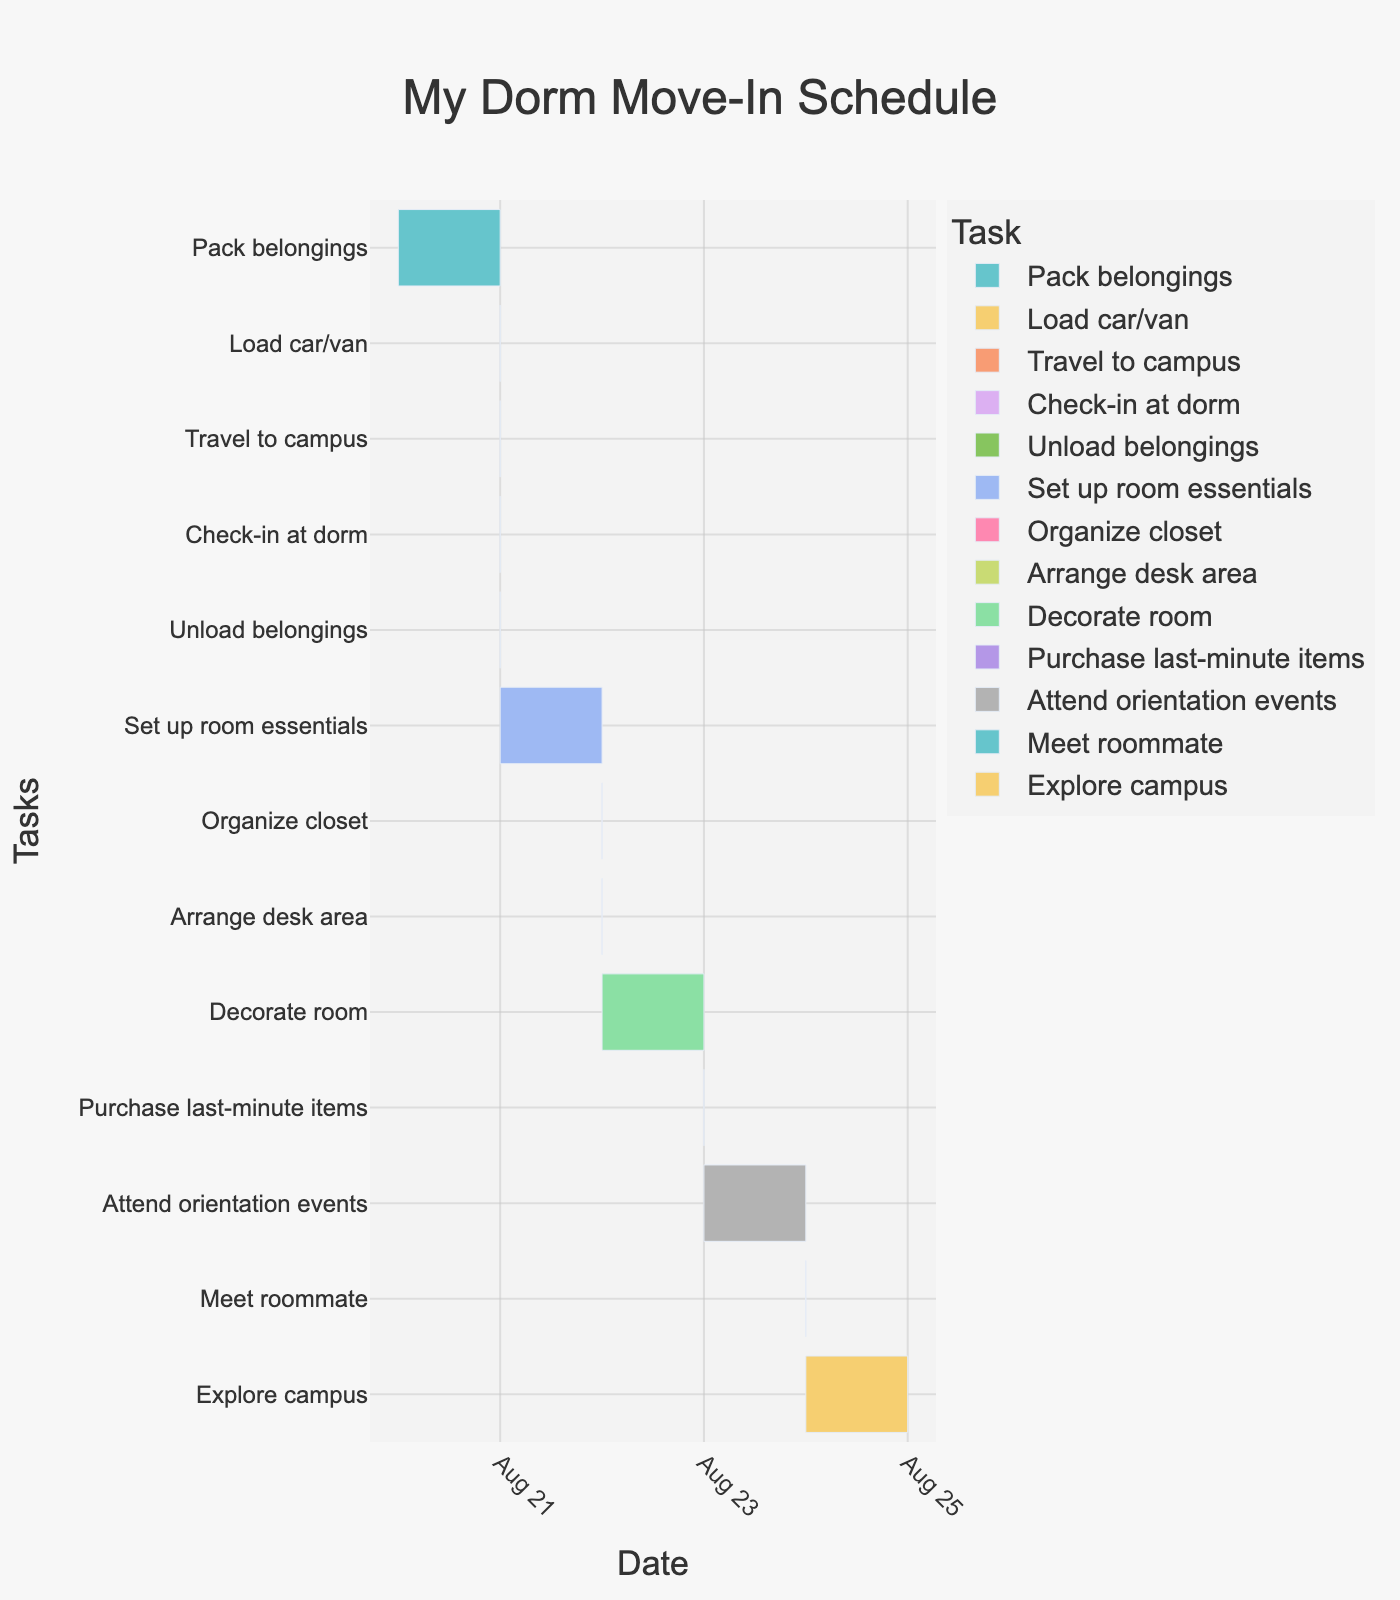What's the title of the Gantt Chart? The title of a chart is usually found at the top, indicating the subject or purpose of the chart.
Answer: My Dorm Move-In Schedule What is the duration of the 'Pack belongings' task? By looking at the task's bar on the chart, we can see that it starts on August 20 and ends on August 21. The duration is stated as 8 hours.
Answer: 8 hours How many tasks are scheduled to start on August 21? One can count the bars starting on August 21 directly from the chart. The tasks are 'Pack belongings', 'Load car/van', 'Travel to campus', 'Check-in at dorm', 'Unload belongings', and 'Set up room essentials'.
Answer: 6 Which task has the longest duration? By comparing the lengths of the bars on the chart, 'Attend orientation events' can be seen lasting from August 23 to August 24 with a duration of 8 hours.
Answer: Attend orientation events Which tasks overlap on August 23? By visually checking the tasks that span across August 23, 'Decorate room', 'Purchase last-minute items', and 'Attend orientation events' overlap on that date.
Answer: Decorate room, Purchase last-minute items, Attend orientation events How many hours in total are spent on tasks starting on August 22? Summing the durations of the tasks that start on August 22: 'Organize closet' (3 hours), 'Arrange desk area' (2 hours), and 'Decorate room' (4 hours).
Answer: 9 hours Compare the durations of 'Explore campus' and 'Set up room essentials'. Which one takes longer? By comparing the durations directly from the chart, 'Explore campus' lasts for 6 hours from August 24 to August 25, while 'Set up room essentials' also lasts for 6 hours from August 21 to August 22.
Answer: They take the same time How long is the gap between 'Unload belongings' and 'Organize closet'? 'Unload belongings' ends on August 21 and 'Organize closet' starts on August 22. There is a day gap, translating to a gap of several hours.
Answer: 12 hours (approximately) Which task is scheduled immediately after 'Meet roommate'? By looking at the timelines, 'Explore campus' follows directly after 'Meet roommate'.
Answer: Explore campus What are the exact start and end times for 'Travel to campus'? Refer to the hover information in the plot; it indicates 'Travel to campus' starts and ends on August 21, from 8 AM to 12 PM.
Answer: August 21, 8 AM to 12 PM 